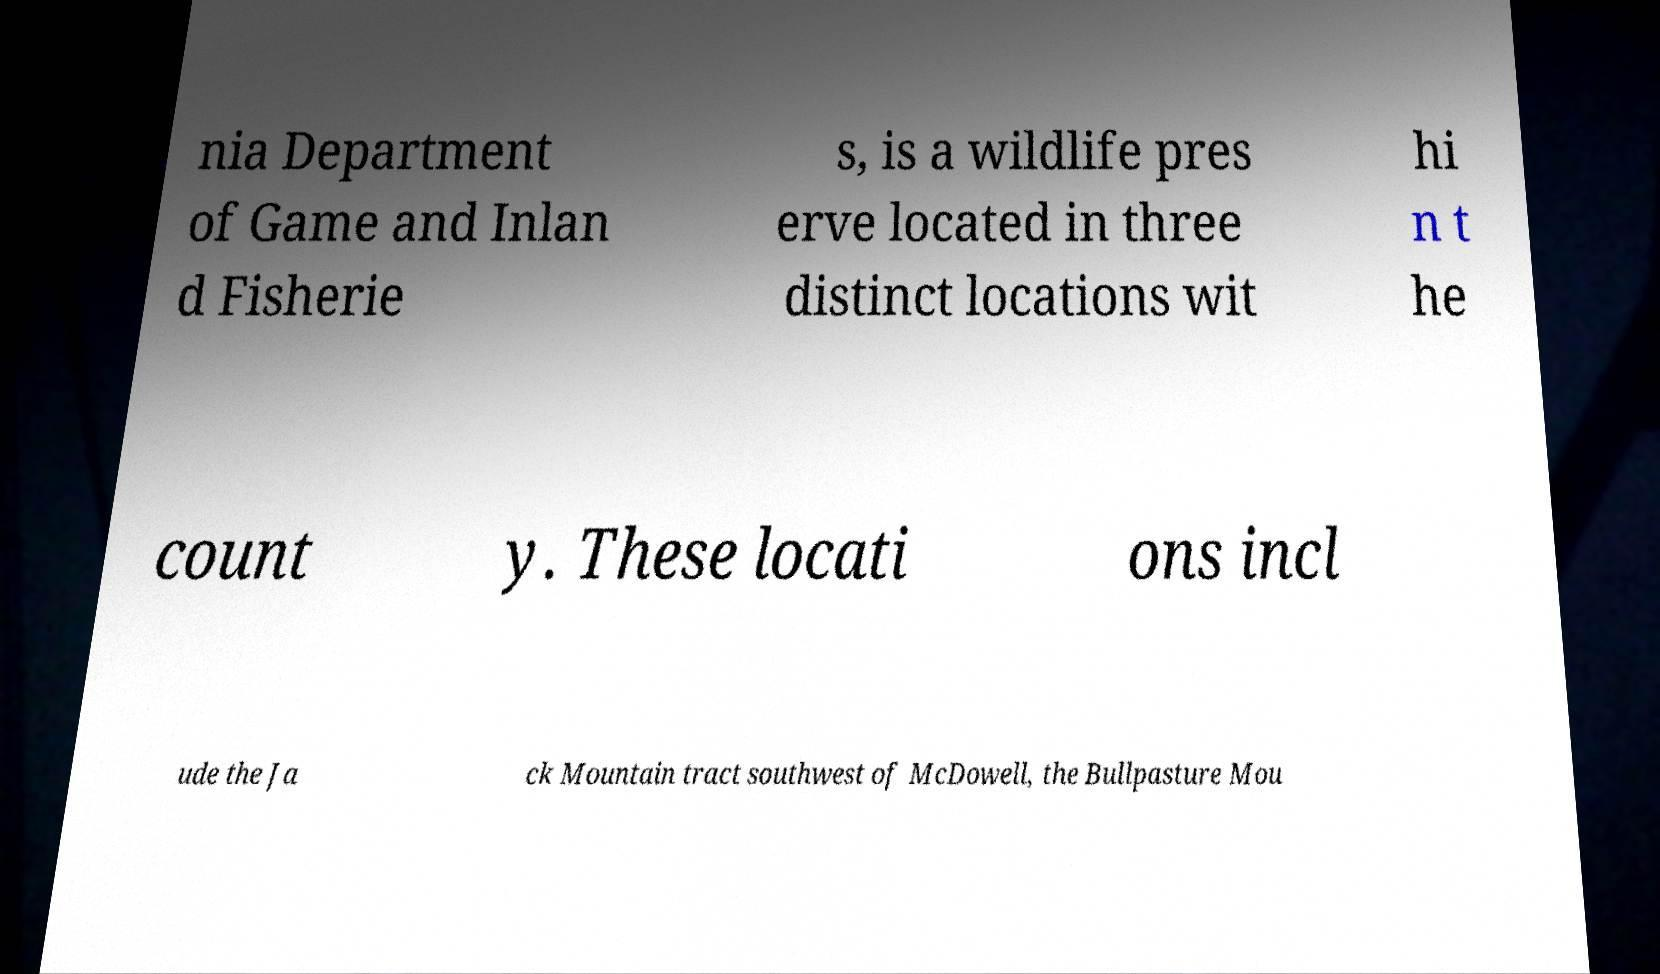For documentation purposes, I need the text within this image transcribed. Could you provide that? nia Department of Game and Inlan d Fisherie s, is a wildlife pres erve located in three distinct locations wit hi n t he count y. These locati ons incl ude the Ja ck Mountain tract southwest of McDowell, the Bullpasture Mou 